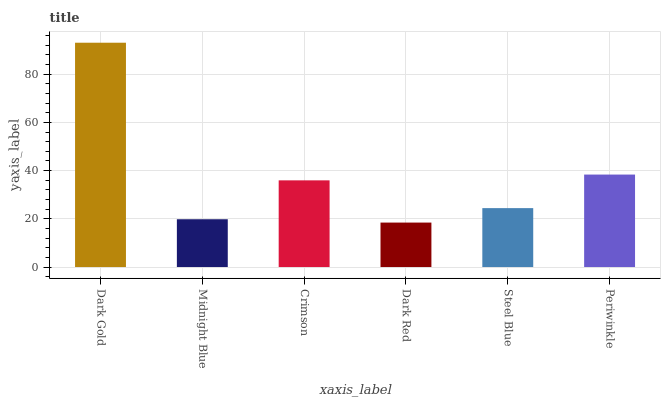Is Midnight Blue the minimum?
Answer yes or no. No. Is Midnight Blue the maximum?
Answer yes or no. No. Is Dark Gold greater than Midnight Blue?
Answer yes or no. Yes. Is Midnight Blue less than Dark Gold?
Answer yes or no. Yes. Is Midnight Blue greater than Dark Gold?
Answer yes or no. No. Is Dark Gold less than Midnight Blue?
Answer yes or no. No. Is Crimson the high median?
Answer yes or no. Yes. Is Steel Blue the low median?
Answer yes or no. Yes. Is Steel Blue the high median?
Answer yes or no. No. Is Crimson the low median?
Answer yes or no. No. 